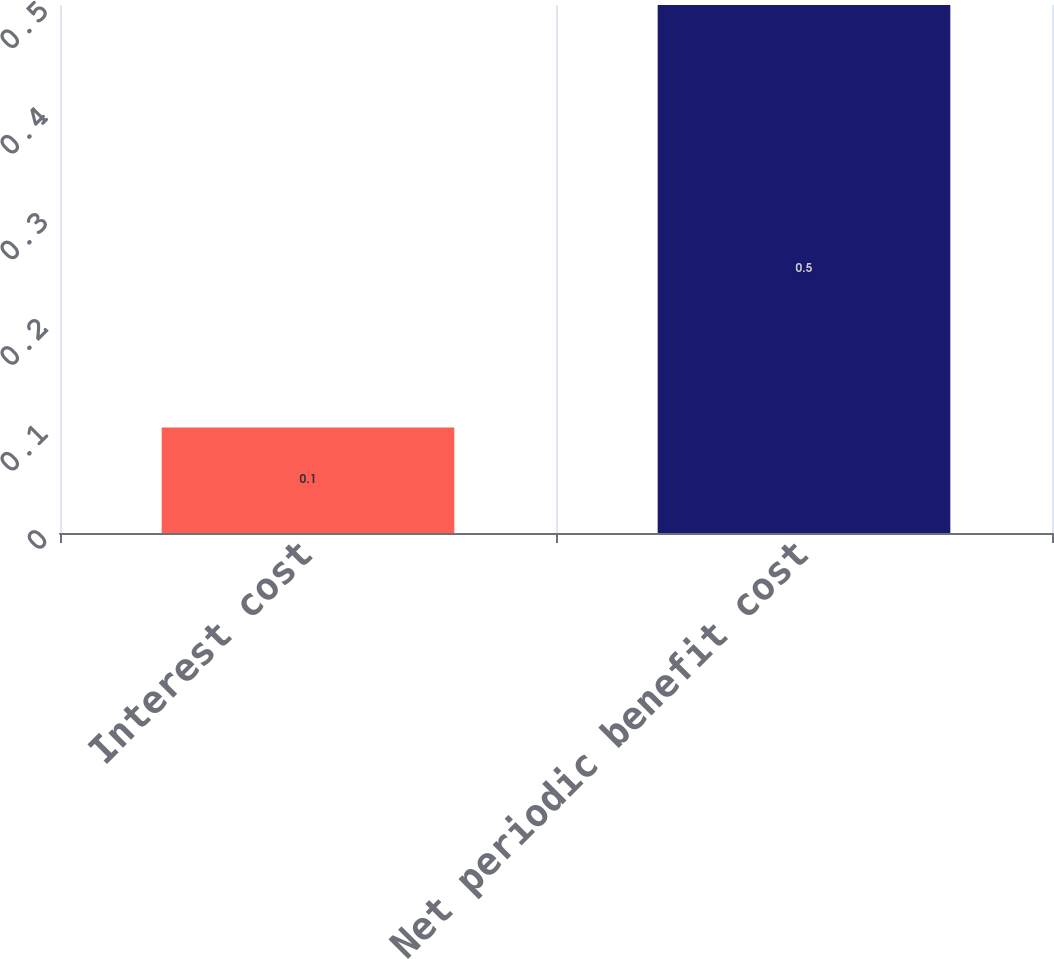Convert chart to OTSL. <chart><loc_0><loc_0><loc_500><loc_500><bar_chart><fcel>Interest cost<fcel>Net periodic benefit cost<nl><fcel>0.1<fcel>0.5<nl></chart> 